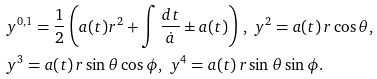<formula> <loc_0><loc_0><loc_500><loc_500>& y ^ { 0 , 1 } = \frac { 1 } { 2 } \left ( a ( t ) r ^ { 2 } + \int \frac { d t } { \dot { a } } \pm a ( t ) \right ) \, , \ y ^ { 2 } = a ( t ) \, r \cos \theta , \\ & y ^ { 3 } = a ( t ) \, r \sin \theta \cos \phi , \ y ^ { 4 } = a ( t ) \, r \sin \theta \sin \phi .</formula> 